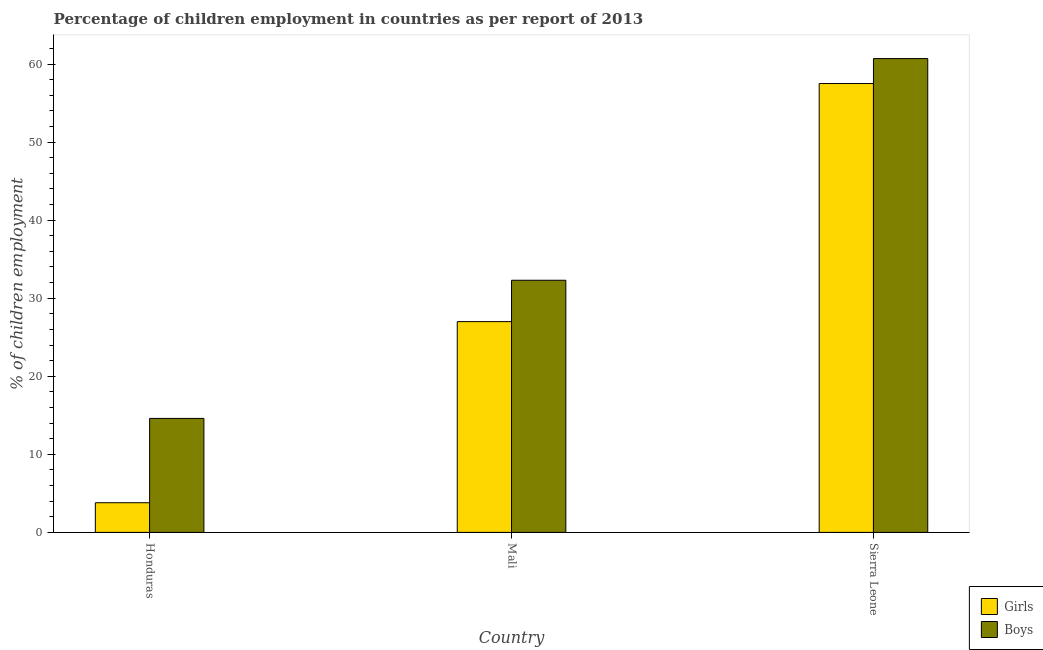Are the number of bars per tick equal to the number of legend labels?
Give a very brief answer. Yes. Are the number of bars on each tick of the X-axis equal?
Your answer should be very brief. Yes. How many bars are there on the 2nd tick from the left?
Offer a very short reply. 2. What is the label of the 3rd group of bars from the left?
Give a very brief answer. Sierra Leone. In how many cases, is the number of bars for a given country not equal to the number of legend labels?
Offer a terse response. 0. What is the percentage of employed girls in Mali?
Provide a short and direct response. 27. Across all countries, what is the maximum percentage of employed boys?
Offer a terse response. 60.7. In which country was the percentage of employed boys maximum?
Keep it short and to the point. Sierra Leone. In which country was the percentage of employed girls minimum?
Offer a very short reply. Honduras. What is the total percentage of employed boys in the graph?
Ensure brevity in your answer.  107.6. What is the difference between the percentage of employed girls in Mali and that in Sierra Leone?
Your answer should be compact. -30.5. What is the difference between the percentage of employed boys in Honduras and the percentage of employed girls in Mali?
Provide a succinct answer. -12.4. What is the average percentage of employed boys per country?
Provide a short and direct response. 35.87. What is the difference between the percentage of employed girls and percentage of employed boys in Mali?
Keep it short and to the point. -5.3. What is the ratio of the percentage of employed girls in Mali to that in Sierra Leone?
Your answer should be compact. 0.47. Is the percentage of employed boys in Honduras less than that in Sierra Leone?
Give a very brief answer. Yes. What is the difference between the highest and the second highest percentage of employed girls?
Your answer should be compact. 30.5. What is the difference between the highest and the lowest percentage of employed girls?
Offer a terse response. 53.7. In how many countries, is the percentage of employed girls greater than the average percentage of employed girls taken over all countries?
Offer a terse response. 1. What does the 2nd bar from the left in Honduras represents?
Offer a very short reply. Boys. What does the 1st bar from the right in Sierra Leone represents?
Give a very brief answer. Boys. How many bars are there?
Your answer should be very brief. 6. What is the difference between two consecutive major ticks on the Y-axis?
Provide a succinct answer. 10. Does the graph contain any zero values?
Give a very brief answer. No. What is the title of the graph?
Ensure brevity in your answer.  Percentage of children employment in countries as per report of 2013. Does "Canada" appear as one of the legend labels in the graph?
Provide a succinct answer. No. What is the label or title of the Y-axis?
Make the answer very short. % of children employment. What is the % of children employment of Boys in Mali?
Provide a short and direct response. 32.3. What is the % of children employment in Girls in Sierra Leone?
Ensure brevity in your answer.  57.5. What is the % of children employment in Boys in Sierra Leone?
Offer a terse response. 60.7. Across all countries, what is the maximum % of children employment of Girls?
Your answer should be compact. 57.5. Across all countries, what is the maximum % of children employment of Boys?
Your answer should be very brief. 60.7. Across all countries, what is the minimum % of children employment in Boys?
Ensure brevity in your answer.  14.6. What is the total % of children employment in Girls in the graph?
Your answer should be very brief. 88.3. What is the total % of children employment in Boys in the graph?
Provide a short and direct response. 107.6. What is the difference between the % of children employment of Girls in Honduras and that in Mali?
Give a very brief answer. -23.2. What is the difference between the % of children employment of Boys in Honduras and that in Mali?
Your answer should be very brief. -17.7. What is the difference between the % of children employment of Girls in Honduras and that in Sierra Leone?
Keep it short and to the point. -53.7. What is the difference between the % of children employment of Boys in Honduras and that in Sierra Leone?
Make the answer very short. -46.1. What is the difference between the % of children employment of Girls in Mali and that in Sierra Leone?
Keep it short and to the point. -30.5. What is the difference between the % of children employment of Boys in Mali and that in Sierra Leone?
Your answer should be compact. -28.4. What is the difference between the % of children employment of Girls in Honduras and the % of children employment of Boys in Mali?
Provide a succinct answer. -28.5. What is the difference between the % of children employment of Girls in Honduras and the % of children employment of Boys in Sierra Leone?
Ensure brevity in your answer.  -56.9. What is the difference between the % of children employment in Girls in Mali and the % of children employment in Boys in Sierra Leone?
Give a very brief answer. -33.7. What is the average % of children employment of Girls per country?
Keep it short and to the point. 29.43. What is the average % of children employment of Boys per country?
Offer a very short reply. 35.87. What is the difference between the % of children employment in Girls and % of children employment in Boys in Sierra Leone?
Your answer should be compact. -3.2. What is the ratio of the % of children employment of Girls in Honduras to that in Mali?
Give a very brief answer. 0.14. What is the ratio of the % of children employment of Boys in Honduras to that in Mali?
Provide a short and direct response. 0.45. What is the ratio of the % of children employment of Girls in Honduras to that in Sierra Leone?
Your response must be concise. 0.07. What is the ratio of the % of children employment in Boys in Honduras to that in Sierra Leone?
Offer a terse response. 0.24. What is the ratio of the % of children employment in Girls in Mali to that in Sierra Leone?
Ensure brevity in your answer.  0.47. What is the ratio of the % of children employment in Boys in Mali to that in Sierra Leone?
Ensure brevity in your answer.  0.53. What is the difference between the highest and the second highest % of children employment in Girls?
Provide a succinct answer. 30.5. What is the difference between the highest and the second highest % of children employment in Boys?
Offer a very short reply. 28.4. What is the difference between the highest and the lowest % of children employment in Girls?
Your response must be concise. 53.7. What is the difference between the highest and the lowest % of children employment in Boys?
Provide a succinct answer. 46.1. 